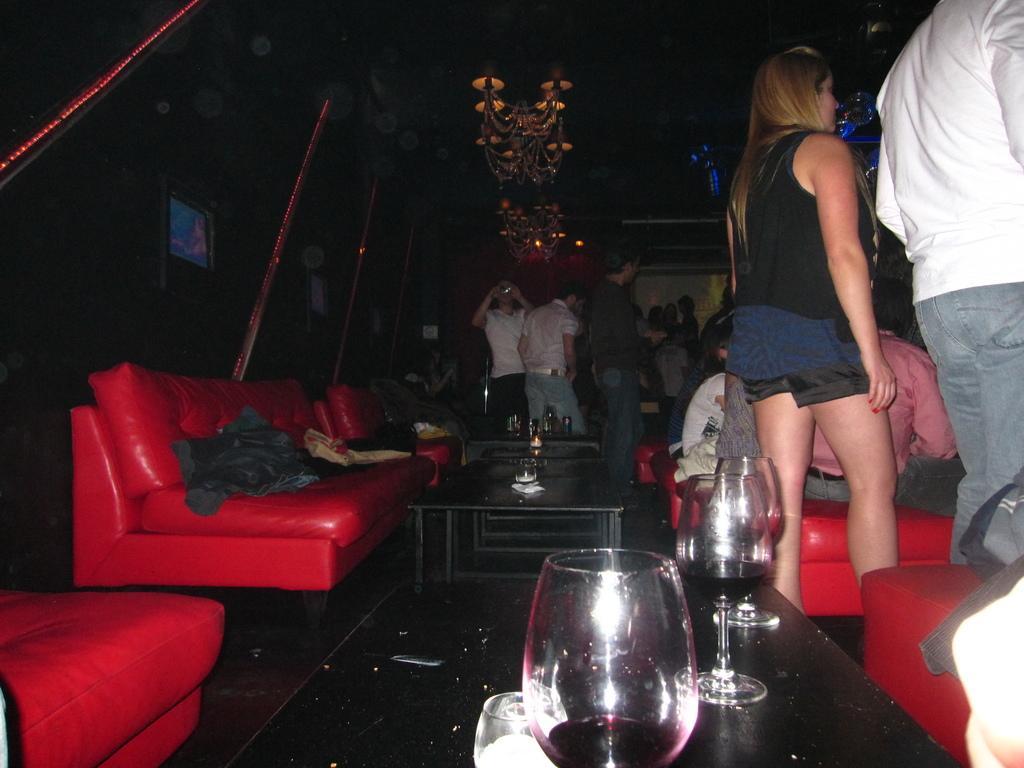Describe this image in one or two sentences. In this image there are group of people and some of them are sitting and some of them are standing. On the left side there are some red couches on the left side there are some red couches. And in the middle of the image there are some tables on that table there are some glasses and bottles are there and on the top there is ceiling and chandeliers are there and on the top of the left corner there are screens. 